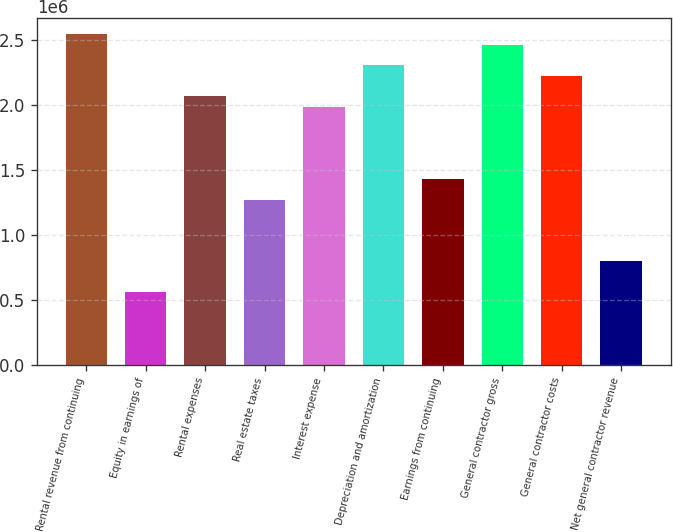<chart> <loc_0><loc_0><loc_500><loc_500><bar_chart><fcel>Rental revenue from continuing<fcel>Equity in earnings of<fcel>Rental expenses<fcel>Real estate taxes<fcel>Interest expense<fcel>Depreciation and amortization<fcel>Earnings from continuing<fcel>General contractor gross<fcel>General contractor costs<fcel>Net general contractor revenue<nl><fcel>2.54236e+06<fcel>556142<fcel>2.06567e+06<fcel>1.27118e+06<fcel>1.98622e+06<fcel>2.30401e+06<fcel>1.43008e+06<fcel>2.46291e+06<fcel>2.22457e+06<fcel>794488<nl></chart> 